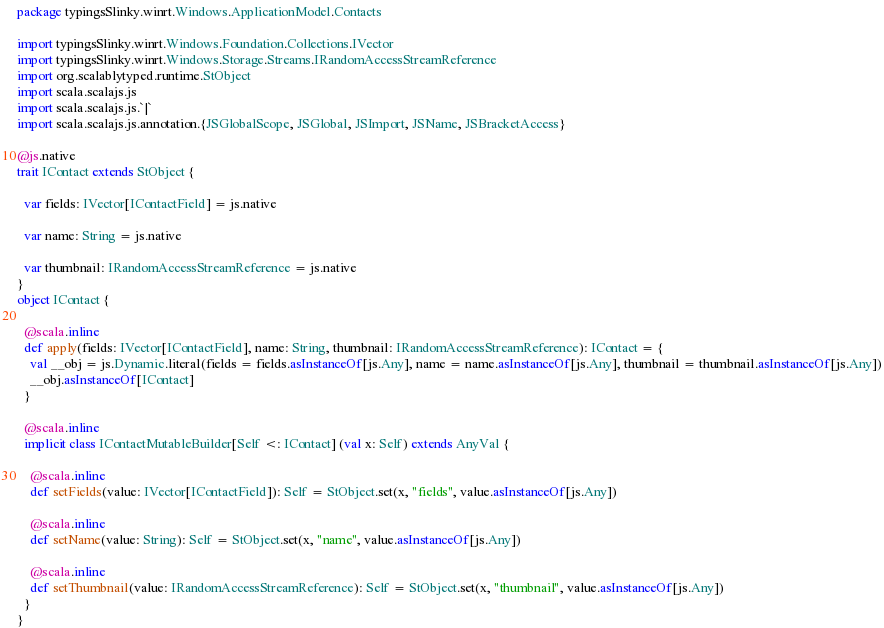<code> <loc_0><loc_0><loc_500><loc_500><_Scala_>package typingsSlinky.winrt.Windows.ApplicationModel.Contacts

import typingsSlinky.winrt.Windows.Foundation.Collections.IVector
import typingsSlinky.winrt.Windows.Storage.Streams.IRandomAccessStreamReference
import org.scalablytyped.runtime.StObject
import scala.scalajs.js
import scala.scalajs.js.`|`
import scala.scalajs.js.annotation.{JSGlobalScope, JSGlobal, JSImport, JSName, JSBracketAccess}

@js.native
trait IContact extends StObject {
  
  var fields: IVector[IContactField] = js.native
  
  var name: String = js.native
  
  var thumbnail: IRandomAccessStreamReference = js.native
}
object IContact {
  
  @scala.inline
  def apply(fields: IVector[IContactField], name: String, thumbnail: IRandomAccessStreamReference): IContact = {
    val __obj = js.Dynamic.literal(fields = fields.asInstanceOf[js.Any], name = name.asInstanceOf[js.Any], thumbnail = thumbnail.asInstanceOf[js.Any])
    __obj.asInstanceOf[IContact]
  }
  
  @scala.inline
  implicit class IContactMutableBuilder[Self <: IContact] (val x: Self) extends AnyVal {
    
    @scala.inline
    def setFields(value: IVector[IContactField]): Self = StObject.set(x, "fields", value.asInstanceOf[js.Any])
    
    @scala.inline
    def setName(value: String): Self = StObject.set(x, "name", value.asInstanceOf[js.Any])
    
    @scala.inline
    def setThumbnail(value: IRandomAccessStreamReference): Self = StObject.set(x, "thumbnail", value.asInstanceOf[js.Any])
  }
}
</code> 